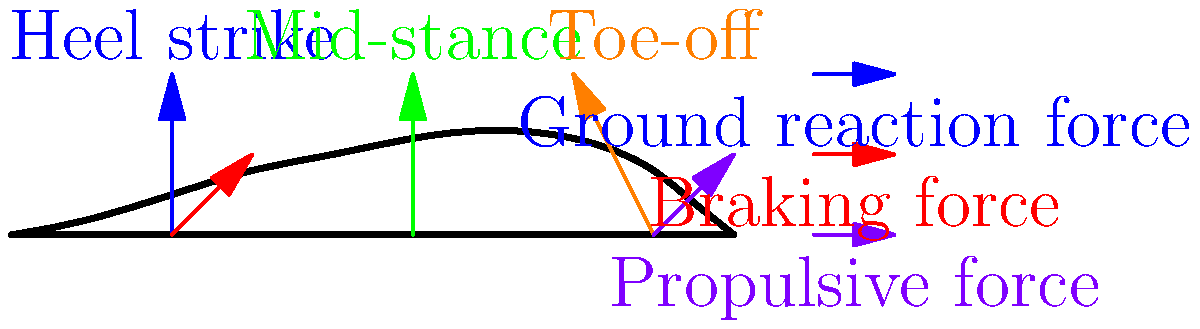As a data scientist specializing in machine learning, you're working on a project to analyze running biomechanics. Given the force vector diagram of a runner's foot during different phases of the gait cycle, which phase exhibits the highest vertical ground reaction force, and how might this information be structured in a dataset for machine learning analysis? To answer this question, let's analyze the force vectors in each phase of the gait cycle:

1. Heel strike:
   - Blue vector (vertical): Represents the initial ground reaction force
   - Red vector (horizontal): Represents the braking force

2. Mid-stance:
   - Green vector (vertical): Represents the ground reaction force during mid-stance

3. Toe-off:
   - Orange vector (diagonal): Represents the ground reaction force during push-off
   - Purple vector (horizontal): Represents the propulsive force

Comparing the vertical components:
- The blue vector (heel strike) and the green vector (mid-stance) appear to have similar magnitudes.
- The orange vector (toe-off) has a smaller vertical component.

Therefore, the highest vertical ground reaction force occurs during the heel strike and mid-stance phases.

For structuring this data in a machine learning dataset:

1. Create time-series data with features for each phase:
   - Time (ms)
   - Phase (categorical: heel strike, mid-stance, toe-off)
   - Vertical force magnitude (N)
   - Horizontal force magnitude (N)
   - Force angle (degrees)

2. Example data structure:
   ```
   Time | Phase      | Vertical_Force | Horizontal_Force | Force_Angle
   0    | Heel_strike| 1000           | 200              | 75
   50   | Mid_stance | 1000           | 0                | 90
   100  | Toe_off    | 800            | 300              | 60
   ```

3. Additional features could include:
   - Runner's weight
   - Running speed
   - Shoe type
   - Surface type

4. This structured data can be used for various machine learning tasks:
   - Classification: Predicting gait phase based on force data
   - Regression: Estimating force magnitudes or angles
   - Anomaly detection: Identifying unusual gait patterns

5. Time-series analysis techniques like LSTM or 1D CNN could be applied to analyze the sequential nature of the gait cycle.
Answer: Heel strike and mid-stance; structure as time-series data with phase, force magnitude, and angle features. 